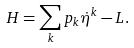<formula> <loc_0><loc_0><loc_500><loc_500>H = \sum _ { k } p _ { k } \dot { \eta } ^ { k } - L .</formula> 